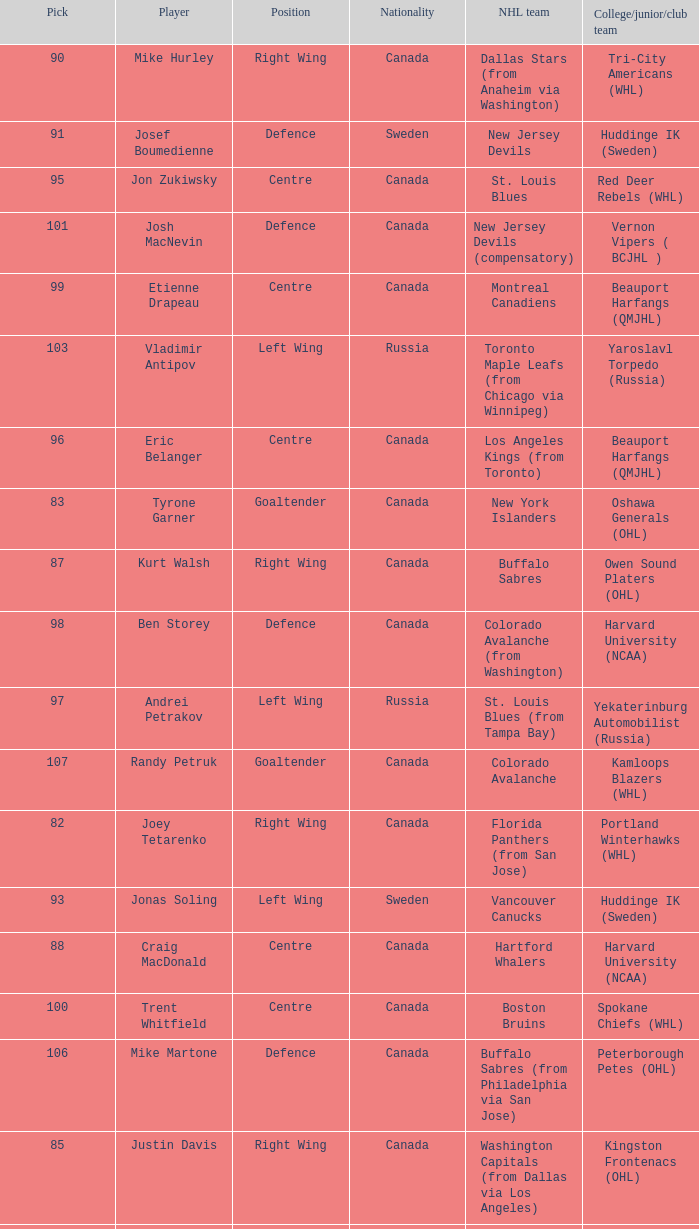What position does Antti-Jussi Niemi play? Defence. Parse the table in full. {'header': ['Pick', 'Player', 'Position', 'Nationality', 'NHL team', 'College/junior/club team'], 'rows': [['90', 'Mike Hurley', 'Right Wing', 'Canada', 'Dallas Stars (from Anaheim via Washington)', 'Tri-City Americans (WHL)'], ['91', 'Josef Boumedienne', 'Defence', 'Sweden', 'New Jersey Devils', 'Huddinge IK (Sweden)'], ['95', 'Jon Zukiwsky', 'Centre', 'Canada', 'St. Louis Blues', 'Red Deer Rebels (WHL)'], ['101', 'Josh MacNevin', 'Defence', 'Canada', 'New Jersey Devils (compensatory)', 'Vernon Vipers ( BCJHL )'], ['99', 'Etienne Drapeau', 'Centre', 'Canada', 'Montreal Canadiens', 'Beauport Harfangs (QMJHL)'], ['103', 'Vladimir Antipov', 'Left Wing', 'Russia', 'Toronto Maple Leafs (from Chicago via Winnipeg)', 'Yaroslavl Torpedo (Russia)'], ['96', 'Eric Belanger', 'Centre', 'Canada', 'Los Angeles Kings (from Toronto)', 'Beauport Harfangs (QMJHL)'], ['83', 'Tyrone Garner', 'Goaltender', 'Canada', 'New York Islanders', 'Oshawa Generals (OHL)'], ['87', 'Kurt Walsh', 'Right Wing', 'Canada', 'Buffalo Sabres', 'Owen Sound Platers (OHL)'], ['98', 'Ben Storey', 'Defence', 'Canada', 'Colorado Avalanche (from Washington)', 'Harvard University (NCAA)'], ['97', 'Andrei Petrakov', 'Left Wing', 'Russia', 'St. Louis Blues (from Tampa Bay)', 'Yekaterinburg Automobilist (Russia)'], ['107', 'Randy Petruk', 'Goaltender', 'Canada', 'Colorado Avalanche', 'Kamloops Blazers (WHL)'], ['82', 'Joey Tetarenko', 'Right Wing', 'Canada', 'Florida Panthers (from San Jose)', 'Portland Winterhawks (WHL)'], ['93', 'Jonas Soling', 'Left Wing', 'Sweden', 'Vancouver Canucks', 'Huddinge IK (Sweden)'], ['88', 'Craig MacDonald', 'Centre', 'Canada', 'Hartford Whalers', 'Harvard University (NCAA)'], ['100', 'Trent Whitfield', 'Centre', 'Canada', 'Boston Bruins', 'Spokane Chiefs (WHL)'], ['106', 'Mike Martone', 'Defence', 'Canada', 'Buffalo Sabres (from Philadelphia via San Jose)', 'Peterborough Petes (OHL)'], ['85', 'Justin Davis', 'Right Wing', 'Canada', 'Washington Capitals (from Dallas via Los Angeles)', 'Kingston Frontenacs (OHL)'], ['102', 'Matt Bradley', 'Right Wing', 'Canada', 'San Jose Sharks (from Florida)', 'Kingston Frontenacs (OHL)'], ['104', 'Steve Wasylko', 'Centre', 'Canada', 'Hartford Whalers (from New York Rangers)', 'Detroit Whalers (OHL)'], ['81', 'Antti-Jussi Niemi', 'Defence', 'Finland', 'Ottawa Senators', 'Jokerit (Finland)'], ['86', 'Jason Sessa', 'Right Wing', 'United States', 'Toronto Maple Leafs (from Edmonton)', 'Lake Superior State University (NCAA)'], ['105', 'Michal Rozsival', 'Defence', 'Czech Republic', 'Pittsburgh Penguins', 'HC Dukla Jihlava (Czech.)'], ['94', 'Christian Lefebvre', 'Defence', 'Canada', 'Calgary Flames', 'Granby Prédateurs (QMJHL)'], ['89', 'Toni Lydman', 'Defence', 'Finland', 'Calgary Flames (compensatory)', 'Reipas Lahti (Finland)']]} 